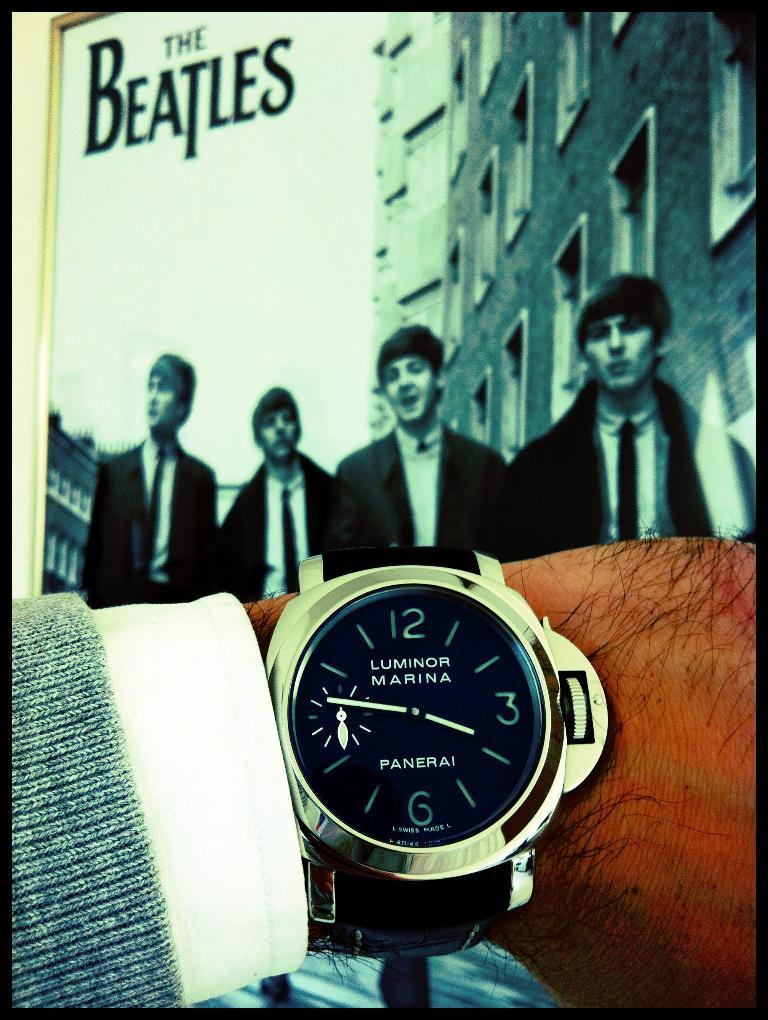<image>
Summarize the visual content of the image. Person wearing a watch which says "Luminor Marina" on it. 